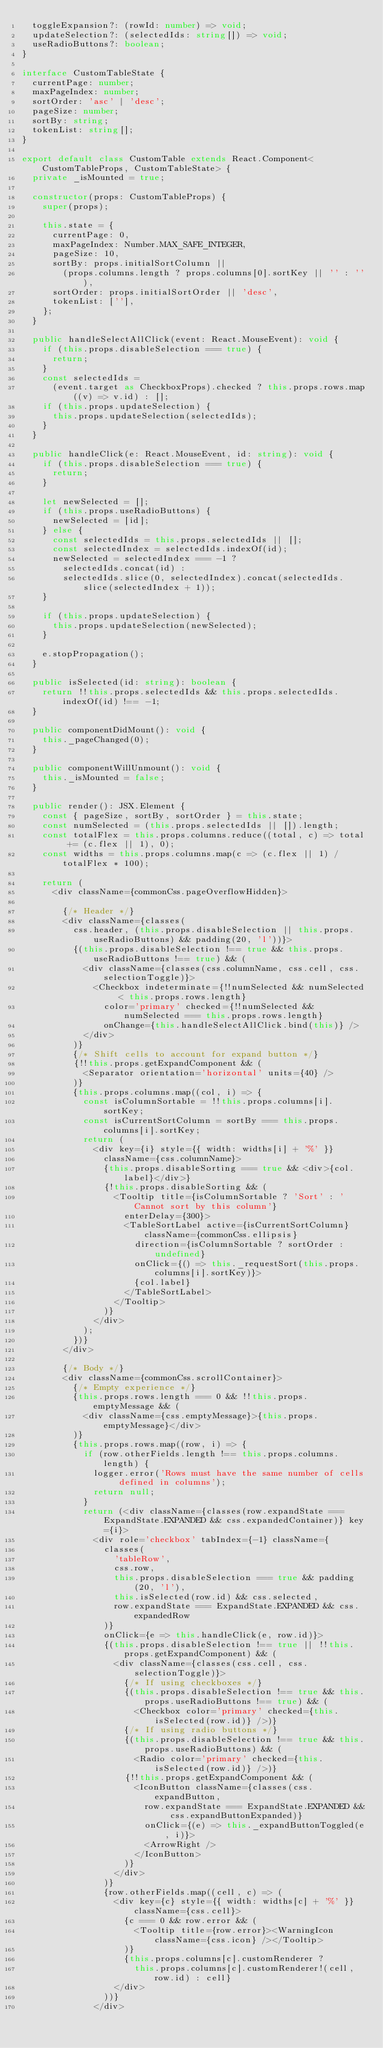Convert code to text. <code><loc_0><loc_0><loc_500><loc_500><_TypeScript_>  toggleExpansion?: (rowId: number) => void;
  updateSelection?: (selectedIds: string[]) => void;
  useRadioButtons?: boolean;
}

interface CustomTableState {
  currentPage: number;
  maxPageIndex: number;
  sortOrder: 'asc' | 'desc';
  pageSize: number;
  sortBy: string;
  tokenList: string[];
}

export default class CustomTable extends React.Component<CustomTableProps, CustomTableState> {
  private _isMounted = true;

  constructor(props: CustomTableProps) {
    super(props);

    this.state = {
      currentPage: 0,
      maxPageIndex: Number.MAX_SAFE_INTEGER,
      pageSize: 10,
      sortBy: props.initialSortColumn ||
        (props.columns.length ? props.columns[0].sortKey || '' : ''),
      sortOrder: props.initialSortOrder || 'desc',
      tokenList: [''],
    };
  }

  public handleSelectAllClick(event: React.MouseEvent): void {
    if (this.props.disableSelection === true) {
      return;
    }
    const selectedIds =
      (event.target as CheckboxProps).checked ? this.props.rows.map((v) => v.id) : [];
    if (this.props.updateSelection) {
      this.props.updateSelection(selectedIds);
    }
  }

  public handleClick(e: React.MouseEvent, id: string): void {
    if (this.props.disableSelection === true) {
      return;
    }

    let newSelected = [];
    if (this.props.useRadioButtons) {
      newSelected = [id];
    } else {
      const selectedIds = this.props.selectedIds || [];
      const selectedIndex = selectedIds.indexOf(id);
      newSelected = selectedIndex === -1 ?
        selectedIds.concat(id) :
        selectedIds.slice(0, selectedIndex).concat(selectedIds.slice(selectedIndex + 1));
    }

    if (this.props.updateSelection) {
      this.props.updateSelection(newSelected);
    }

    e.stopPropagation();
  }

  public isSelected(id: string): boolean {
    return !!this.props.selectedIds && this.props.selectedIds.indexOf(id) !== -1;
  }

  public componentDidMount(): void {
    this._pageChanged(0);
  }

  public componentWillUnmount(): void {
    this._isMounted = false;
  }

  public render(): JSX.Element {
    const { pageSize, sortBy, sortOrder } = this.state;
    const numSelected = (this.props.selectedIds || []).length;
    const totalFlex = this.props.columns.reduce((total, c) => total += (c.flex || 1), 0);
    const widths = this.props.columns.map(c => (c.flex || 1) / totalFlex * 100);

    return (
      <div className={commonCss.pageOverflowHidden}>

        {/* Header */}
        <div className={classes(
          css.header, (this.props.disableSelection || this.props.useRadioButtons) && padding(20, 'l'))}>
          {(this.props.disableSelection !== true && this.props.useRadioButtons !== true) && (
            <div className={classes(css.columnName, css.cell, css.selectionToggle)}>
              <Checkbox indeterminate={!!numSelected && numSelected < this.props.rows.length}
                color='primary' checked={!!numSelected && numSelected === this.props.rows.length}
                onChange={this.handleSelectAllClick.bind(this)} />
            </div>
          )}
          {/* Shift cells to account for expand button */}
          {!!this.props.getExpandComponent && (
            <Separator orientation='horizontal' units={40} />
          )}
          {this.props.columns.map((col, i) => {
            const isColumnSortable = !!this.props.columns[i].sortKey;
            const isCurrentSortColumn = sortBy === this.props.columns[i].sortKey;
            return (
              <div key={i} style={{ width: widths[i] + '%' }}
                className={css.columnName}>
                {this.props.disableSorting === true && <div>{col.label}</div>}
                {!this.props.disableSorting && (
                  <Tooltip title={isColumnSortable ? 'Sort' : 'Cannot sort by this column'}
                    enterDelay={300}>
                    <TableSortLabel active={isCurrentSortColumn} className={commonCss.ellipsis}
                      direction={isColumnSortable ? sortOrder : undefined}
                      onClick={() => this._requestSort(this.props.columns[i].sortKey)}>
                      {col.label}
                    </TableSortLabel>
                  </Tooltip>
                )}
              </div>
            );
          })}
        </div>

        {/* Body */}
        <div className={commonCss.scrollContainer}>
          {/* Empty experience */}
          {this.props.rows.length === 0 && !!this.props.emptyMessage && (
            <div className={css.emptyMessage}>{this.props.emptyMessage}</div>
          )}
          {this.props.rows.map((row, i) => {
            if (row.otherFields.length !== this.props.columns.length) {
              logger.error('Rows must have the same number of cells defined in columns');
              return null;
            }
            return (<div className={classes(row.expandState === ExpandState.EXPANDED && css.expandedContainer)} key={i}>
              <div role='checkbox' tabIndex={-1} className={
                classes(
                  'tableRow',
                  css.row,
                  this.props.disableSelection === true && padding(20, 'l'),
                  this.isSelected(row.id) && css.selected,
                  row.expandState === ExpandState.EXPANDED && css.expandedRow
                )}
                onClick={e => this.handleClick(e, row.id)}>
                {(this.props.disableSelection !== true || !!this.props.getExpandComponent) && (
                  <div className={classes(css.cell, css.selectionToggle)}>
                    {/* If using checkboxes */}
                    {(this.props.disableSelection !== true && this.props.useRadioButtons !== true) && (
                      <Checkbox color='primary' checked={this.isSelected(row.id)} />)}
                    {/* If using radio buttons */}
                    {(this.props.disableSelection !== true && this.props.useRadioButtons) && (
                      <Radio color='primary' checked={this.isSelected(row.id)} />)}
                    {!!this.props.getExpandComponent && (
                      <IconButton className={classes(css.expandButton,
                        row.expandState === ExpandState.EXPANDED && css.expandButtonExpanded)}
                        onClick={(e) => this._expandButtonToggled(e, i)}>
                        <ArrowRight />
                      </IconButton>
                    )}
                  </div>
                )}
                {row.otherFields.map((cell, c) => (
                  <div key={c} style={{ width: widths[c] + '%' }} className={css.cell}>
                    {c === 0 && row.error && (
                      <Tooltip title={row.error}><WarningIcon className={css.icon} /></Tooltip>
                    )}
                    {this.props.columns[c].customRenderer ?
                      this.props.columns[c].customRenderer!(cell, row.id) : cell}
                  </div>
                ))}
              </div></code> 